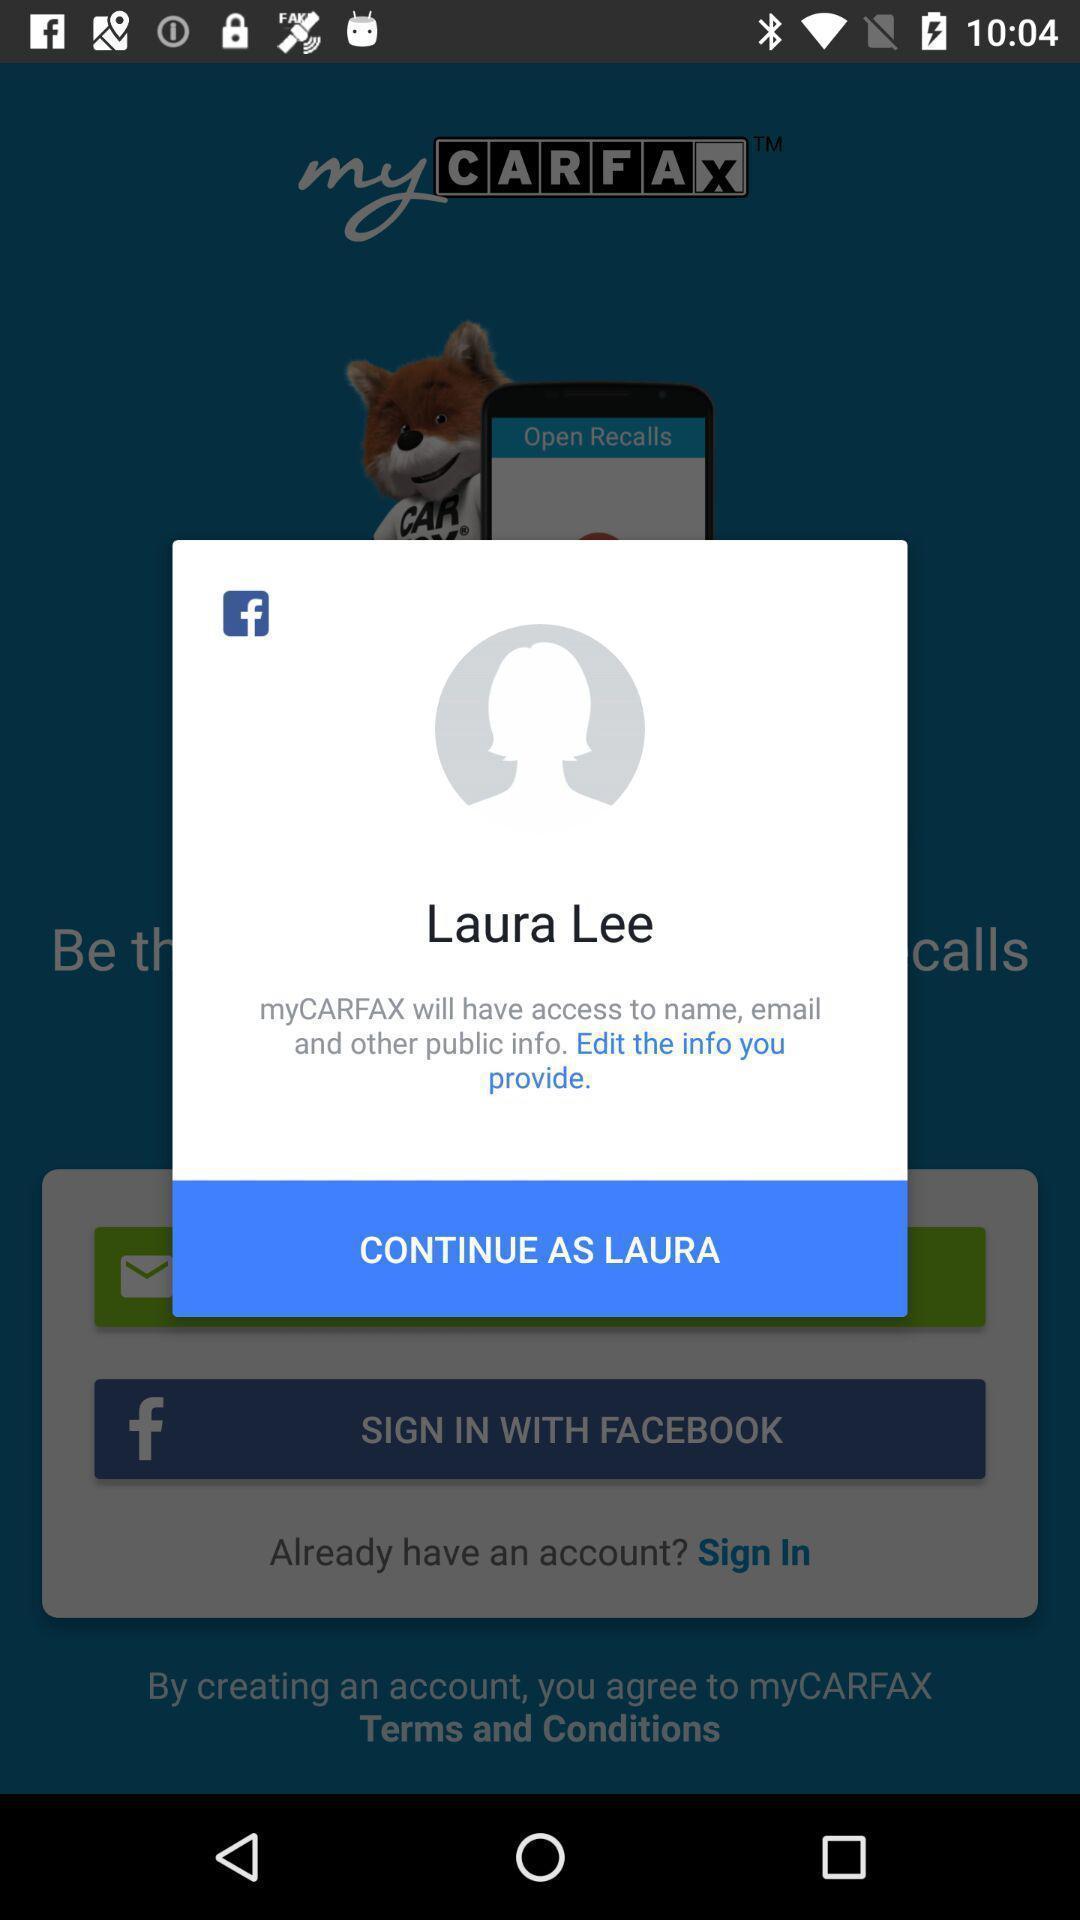Tell me about the visual elements in this screen capture. Pop-up to continue as the user. 